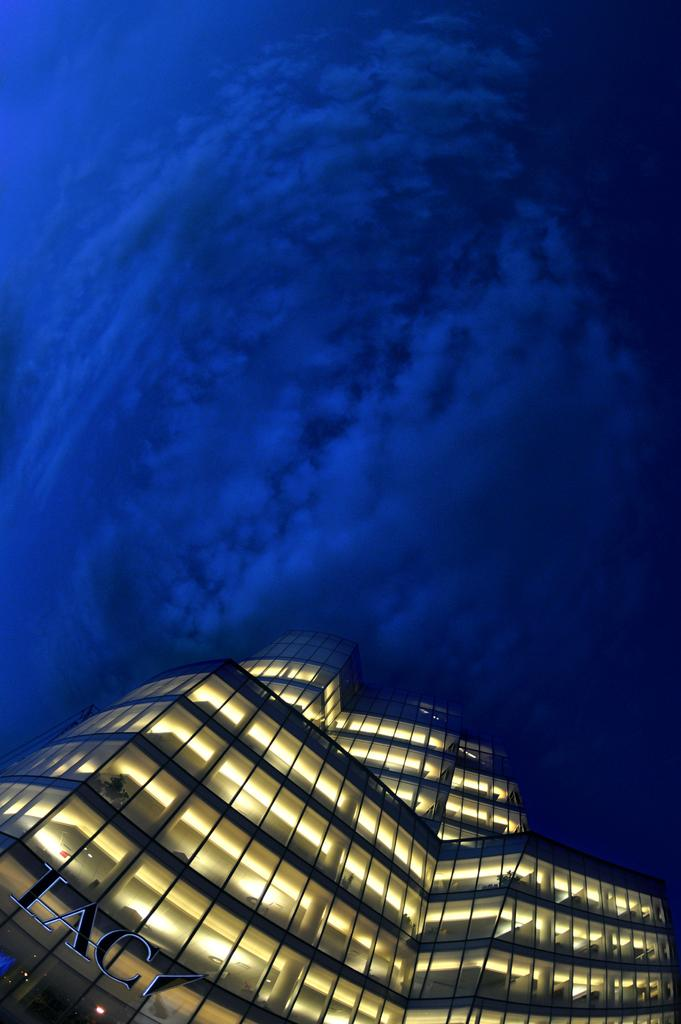What structure is present in the image? There is a building in the image. What is written or displayed on the building? There is some text on the building. What part of the natural environment is visible in the image? The sky is visible in the image. What type of power is being generated by the building in the image? There is no indication in the image that the building is generating any power. Can you tell me how many parcels are being delivered to the building in the image? There is no information about parcels or deliveries in the image. Did an earthquake occur in the area where the building is located, as evidenced by the image? There is no indication in the image that an earthquake has occurred. 